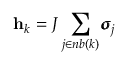Convert formula to latex. <formula><loc_0><loc_0><loc_500><loc_500>\mathbf h _ { k } = J \sum _ { j \in n b ( k ) } \pm b { \sigma } _ { j }</formula> 